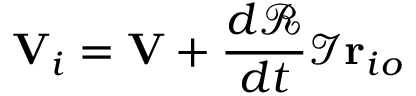Convert formula to latex. <formula><loc_0><loc_0><loc_500><loc_500>V _ { i } = V + { \frac { d { \mathcal { R } } } { d t } } { \mathcal { I } } r _ { i o }</formula> 